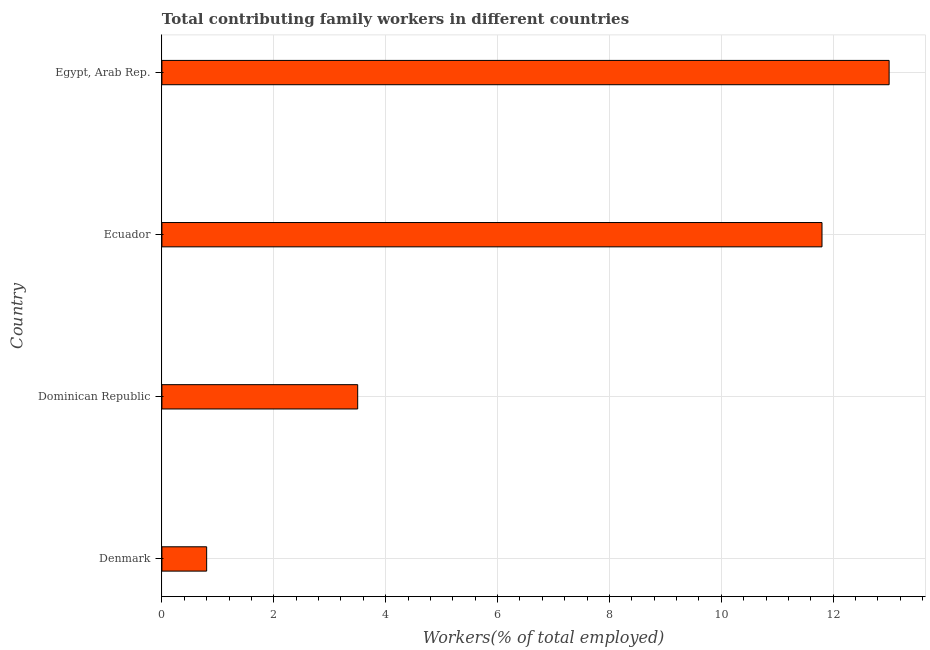Does the graph contain any zero values?
Offer a very short reply. No. What is the title of the graph?
Your response must be concise. Total contributing family workers in different countries. What is the label or title of the X-axis?
Your answer should be compact. Workers(% of total employed). What is the label or title of the Y-axis?
Keep it short and to the point. Country. What is the contributing family workers in Ecuador?
Offer a terse response. 11.8. Across all countries, what is the maximum contributing family workers?
Your answer should be compact. 13. Across all countries, what is the minimum contributing family workers?
Ensure brevity in your answer.  0.8. In which country was the contributing family workers maximum?
Provide a succinct answer. Egypt, Arab Rep. What is the sum of the contributing family workers?
Keep it short and to the point. 29.1. What is the average contributing family workers per country?
Offer a very short reply. 7.28. What is the median contributing family workers?
Your answer should be compact. 7.65. In how many countries, is the contributing family workers greater than 2.4 %?
Offer a terse response. 3. What is the ratio of the contributing family workers in Ecuador to that in Egypt, Arab Rep.?
Provide a succinct answer. 0.91. Is the contributing family workers in Dominican Republic less than that in Egypt, Arab Rep.?
Offer a very short reply. Yes. What is the difference between the highest and the lowest contributing family workers?
Provide a short and direct response. 12.2. How many bars are there?
Keep it short and to the point. 4. Are all the bars in the graph horizontal?
Provide a short and direct response. Yes. What is the difference between two consecutive major ticks on the X-axis?
Provide a short and direct response. 2. What is the Workers(% of total employed) in Denmark?
Your response must be concise. 0.8. What is the Workers(% of total employed) of Dominican Republic?
Your answer should be very brief. 3.5. What is the Workers(% of total employed) of Ecuador?
Ensure brevity in your answer.  11.8. What is the Workers(% of total employed) in Egypt, Arab Rep.?
Your answer should be very brief. 13. What is the difference between the Workers(% of total employed) in Denmark and Dominican Republic?
Provide a succinct answer. -2.7. What is the difference between the Workers(% of total employed) in Denmark and Ecuador?
Provide a succinct answer. -11. What is the ratio of the Workers(% of total employed) in Denmark to that in Dominican Republic?
Ensure brevity in your answer.  0.23. What is the ratio of the Workers(% of total employed) in Denmark to that in Ecuador?
Provide a short and direct response. 0.07. What is the ratio of the Workers(% of total employed) in Denmark to that in Egypt, Arab Rep.?
Your answer should be compact. 0.06. What is the ratio of the Workers(% of total employed) in Dominican Republic to that in Ecuador?
Your response must be concise. 0.3. What is the ratio of the Workers(% of total employed) in Dominican Republic to that in Egypt, Arab Rep.?
Provide a short and direct response. 0.27. What is the ratio of the Workers(% of total employed) in Ecuador to that in Egypt, Arab Rep.?
Keep it short and to the point. 0.91. 